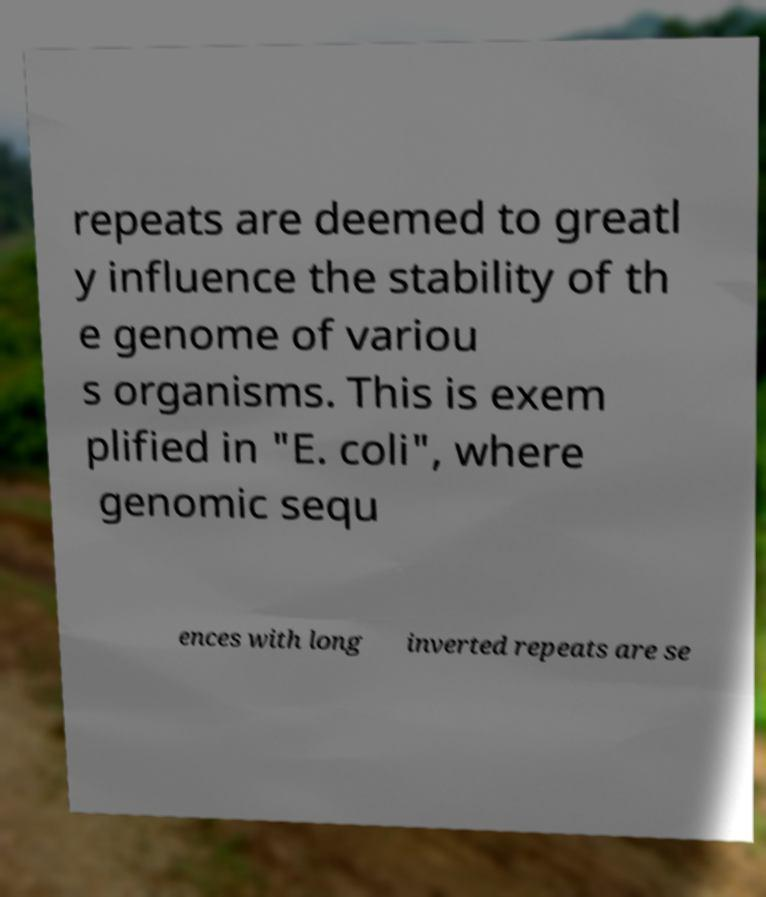There's text embedded in this image that I need extracted. Can you transcribe it verbatim? repeats are deemed to greatl y influence the stability of th e genome of variou s organisms. This is exem plified in "E. coli", where genomic sequ ences with long inverted repeats are se 